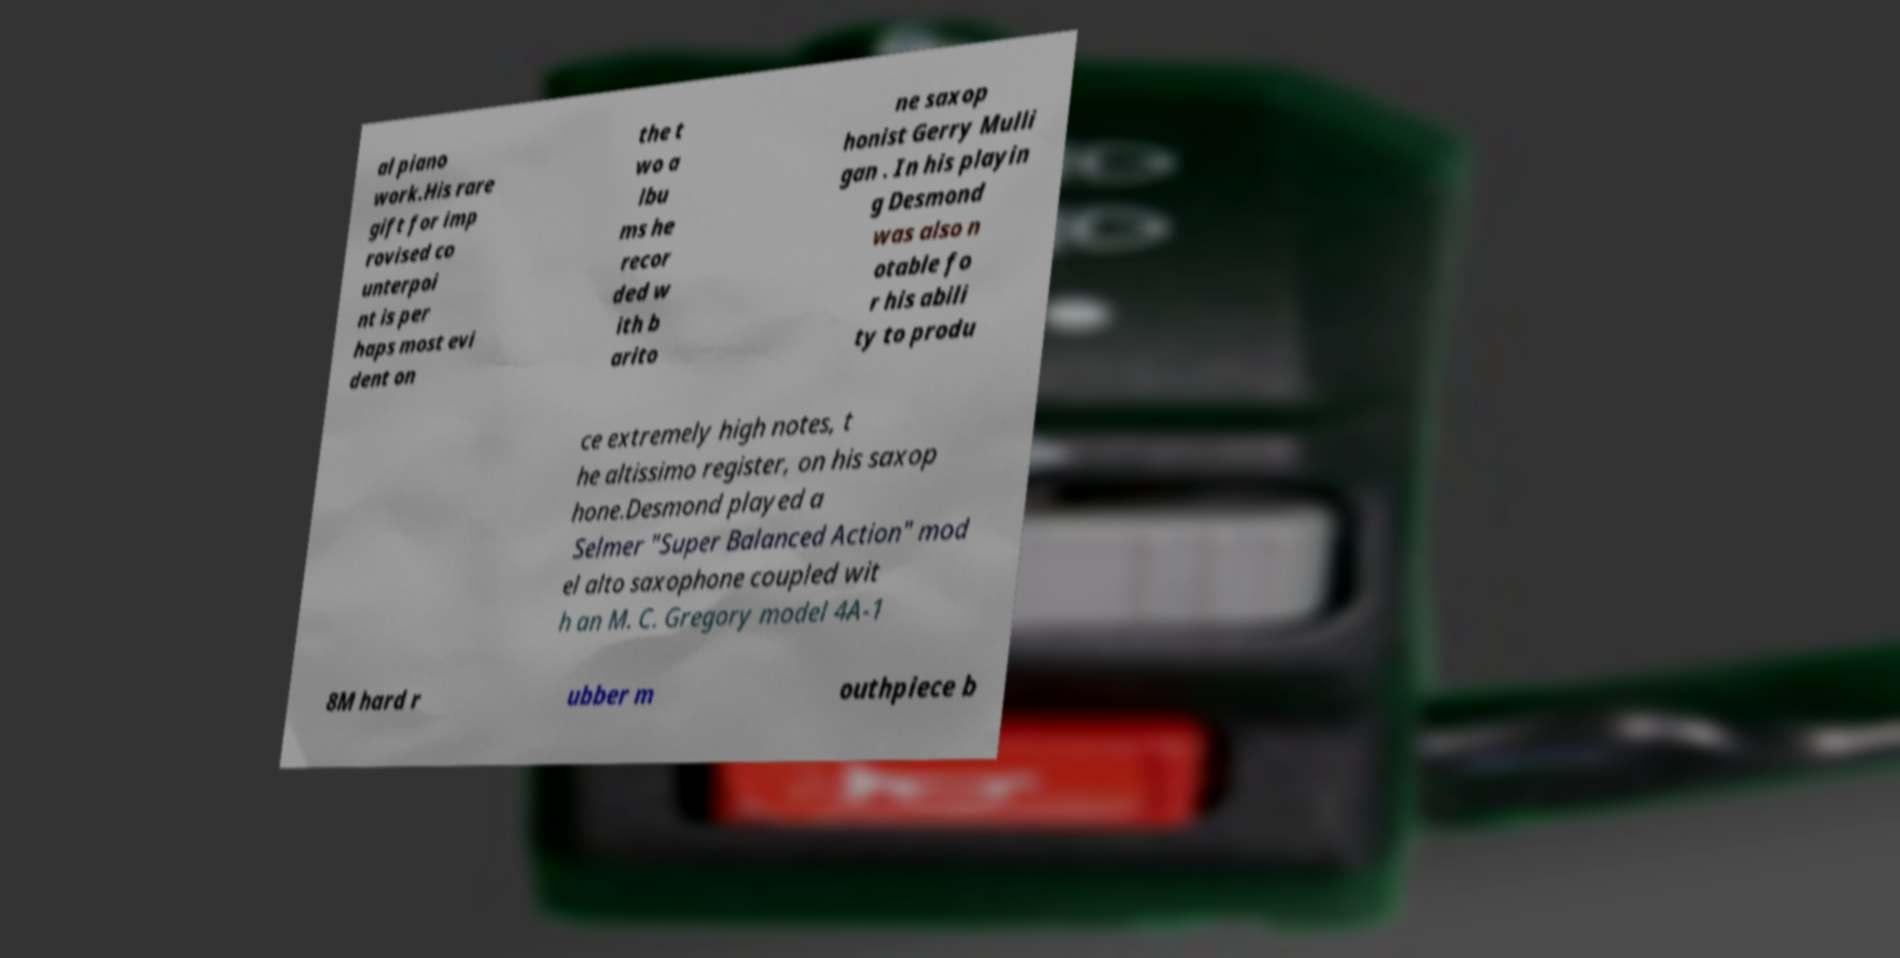Could you extract and type out the text from this image? al piano work.His rare gift for imp rovised co unterpoi nt is per haps most evi dent on the t wo a lbu ms he recor ded w ith b arito ne saxop honist Gerry Mulli gan . In his playin g Desmond was also n otable fo r his abili ty to produ ce extremely high notes, t he altissimo register, on his saxop hone.Desmond played a Selmer "Super Balanced Action" mod el alto saxophone coupled wit h an M. C. Gregory model 4A-1 8M hard r ubber m outhpiece b 